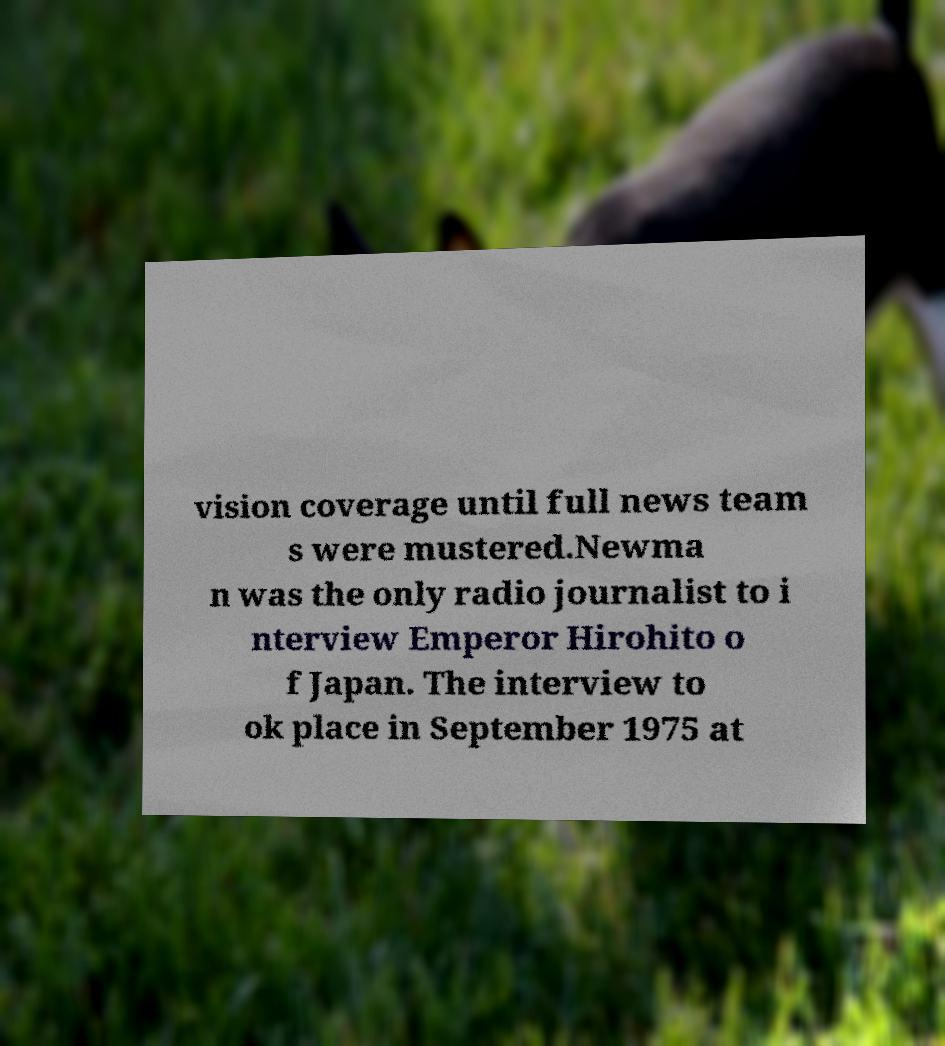For documentation purposes, I need the text within this image transcribed. Could you provide that? vision coverage until full news team s were mustered.Newma n was the only radio journalist to i nterview Emperor Hirohito o f Japan. The interview to ok place in September 1975 at 